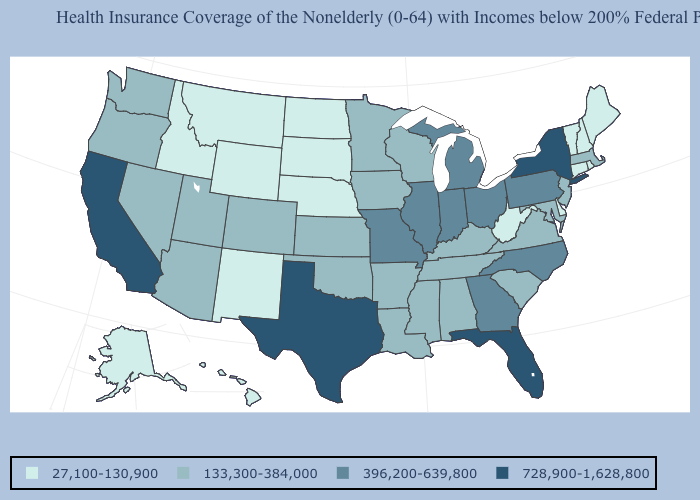Which states hav the highest value in the West?
Short answer required. California. What is the lowest value in states that border New Mexico?
Short answer required. 133,300-384,000. What is the value of Nevada?
Write a very short answer. 133,300-384,000. What is the value of Wisconsin?
Give a very brief answer. 133,300-384,000. Does Washington have the highest value in the USA?
Answer briefly. No. What is the value of Indiana?
Write a very short answer. 396,200-639,800. Does Delaware have the highest value in the South?
Be succinct. No. Does the first symbol in the legend represent the smallest category?
Keep it brief. Yes. Does New York have the highest value in the Northeast?
Answer briefly. Yes. What is the highest value in states that border Iowa?
Be succinct. 396,200-639,800. What is the value of Arkansas?
Be succinct. 133,300-384,000. Name the states that have a value in the range 27,100-130,900?
Keep it brief. Alaska, Connecticut, Delaware, Hawaii, Idaho, Maine, Montana, Nebraska, New Hampshire, New Mexico, North Dakota, Rhode Island, South Dakota, Vermont, West Virginia, Wyoming. Name the states that have a value in the range 728,900-1,628,800?
Answer briefly. California, Florida, New York, Texas. Name the states that have a value in the range 133,300-384,000?
Write a very short answer. Alabama, Arizona, Arkansas, Colorado, Iowa, Kansas, Kentucky, Louisiana, Maryland, Massachusetts, Minnesota, Mississippi, Nevada, New Jersey, Oklahoma, Oregon, South Carolina, Tennessee, Utah, Virginia, Washington, Wisconsin. Name the states that have a value in the range 396,200-639,800?
Quick response, please. Georgia, Illinois, Indiana, Michigan, Missouri, North Carolina, Ohio, Pennsylvania. 